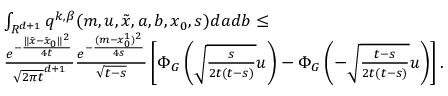<formula> <loc_0><loc_0><loc_500><loc_500>\begin{array} { r l } & { \int _ { R ^ { d + 1 } } q ^ { k , \beta } ( m , u , \tilde { x } , a , b , x _ { 0 } , s ) d a d b \leq } \\ & { \frac { e ^ { - \frac { \| \tilde { x } - \tilde { x } _ { 0 } \| ^ { 2 } } { 4 t } } } { \sqrt { 2 \pi t } ^ { d + 1 } } \frac { e ^ { - \frac { ( m - x _ { 0 } ^ { 1 } ) ^ { 2 } } { 4 s } } } { \sqrt { t - s } } \left [ \Phi _ { G } \left ( \sqrt { \frac { s } { 2 t ( t - s ) } } u \right ) - \Phi _ { G } \left ( - \sqrt { \frac { t - s } { 2 t ( t - s ) } } u \right ) \right ] . } \end{array}</formula> 